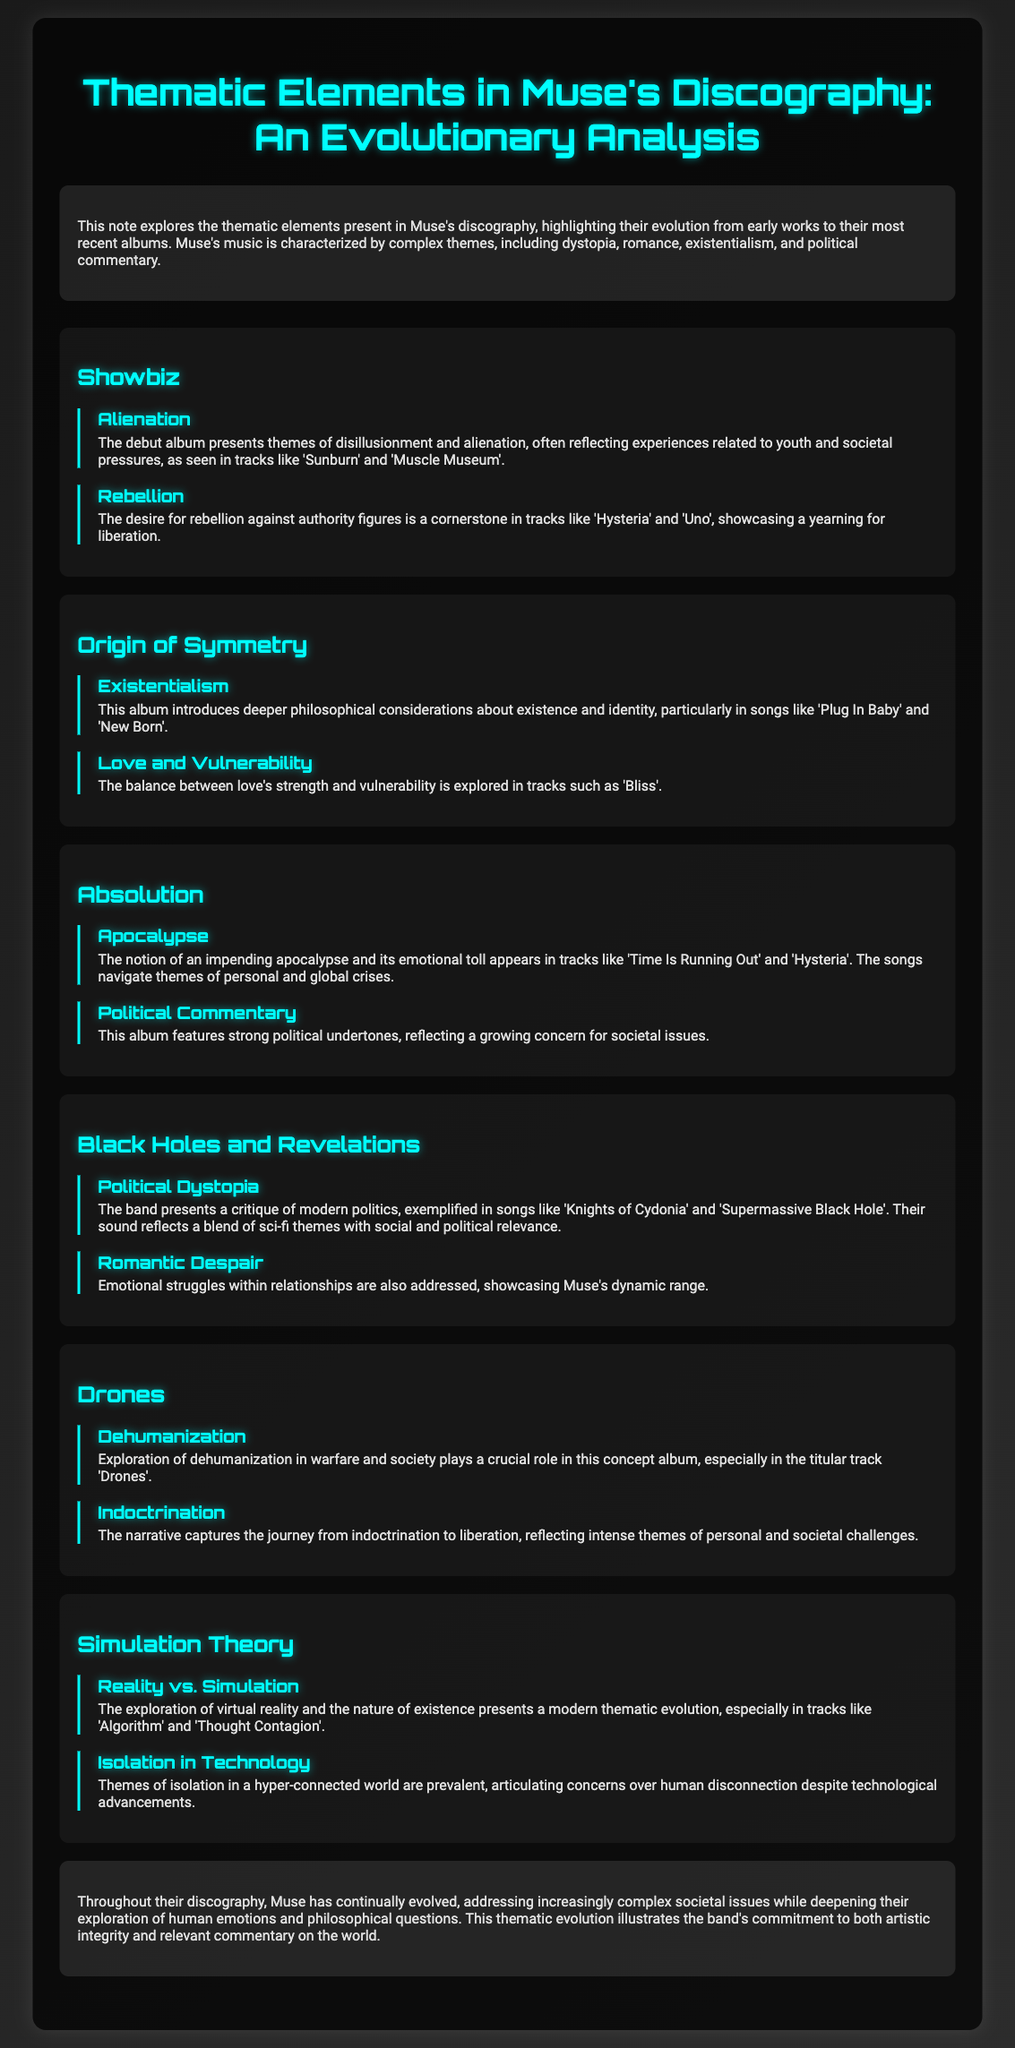What is the title of the document? The title of the document is prominently displayed at the top, reading "Thematic Elements in Muse's Discography: An Evolutionary Analysis".
Answer: Thematic Elements in Muse's Discography: An Evolutionary Analysis Which album is associated with the theme of "Dehumanization"? The document links the theme of dehumanization to the album titled "Drones".
Answer: Drones What does "Simulation Theory" primarily explore? The document states that "Simulation Theory" explores the themes of reality vs. simulation.
Answer: Reality vs. Simulation Which song from "Absolution" reflects political commentary? The document indicates that "Absolution" features strong political undertones, but does not specify a particular song associated; however, one could infer "Hysteria".
Answer: Hysteria What two major themes are present in "Black Holes and Revelations"? The document lists the themes of political dystopia and romantic despair for "Black Holes and Revelations".
Answer: Political Dystopia and Romantic Despair In which album does the theme of "Existentialism" first appear? The theme of existentialism is first introduced in the album "Origin of Symmetry".
Answer: Origin of Symmetry How many themes are discussed for the album "Showbiz"? The document presents two themes associated with the album "Showbiz".
Answer: Two What is the central theme of the album "Drones"? The document highlights that the album "Drones" focuses on dehumanization in warfare and society.
Answer: Dehumanization 